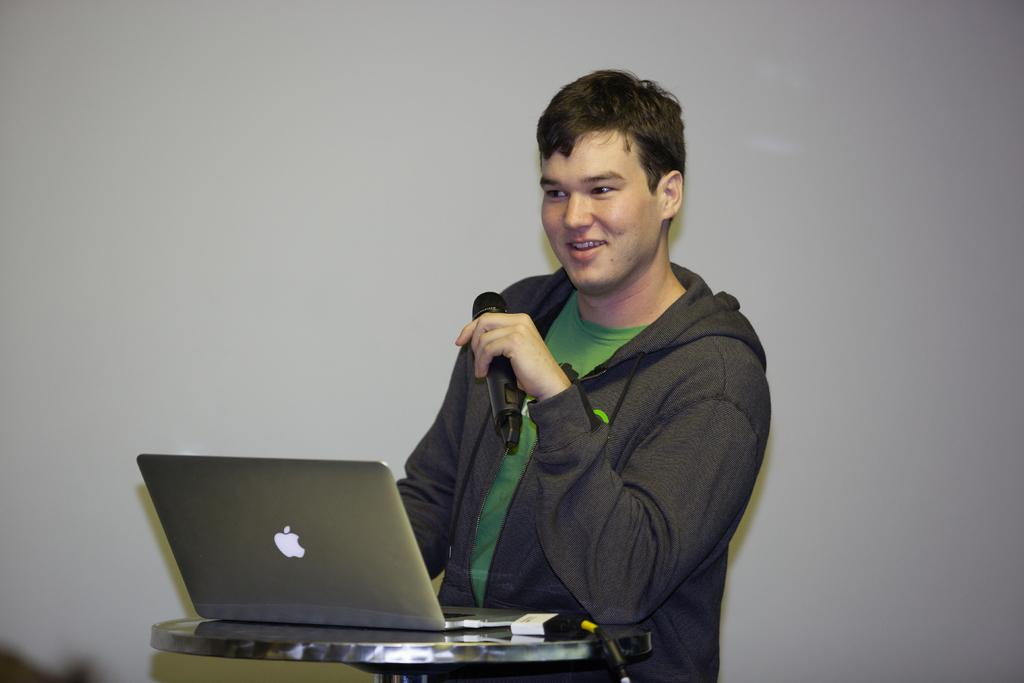Who is present in the image? There is a person in the image. What is the person doing in the image? The person is sitting at a laptop. What can be seen in the background of the image? There is a wall in the background of the image. What type of power source is the person using to charge the laptop in the image? There is no information about a power source or charging in the image; the person is simply sitting at a laptop. 